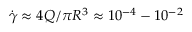<formula> <loc_0><loc_0><loc_500><loc_500>\dot { \gamma } \approx { 4 Q } / { \pi R ^ { 3 } } \approx 1 0 ^ { - 4 } - 1 0 ^ { - 2 }</formula> 